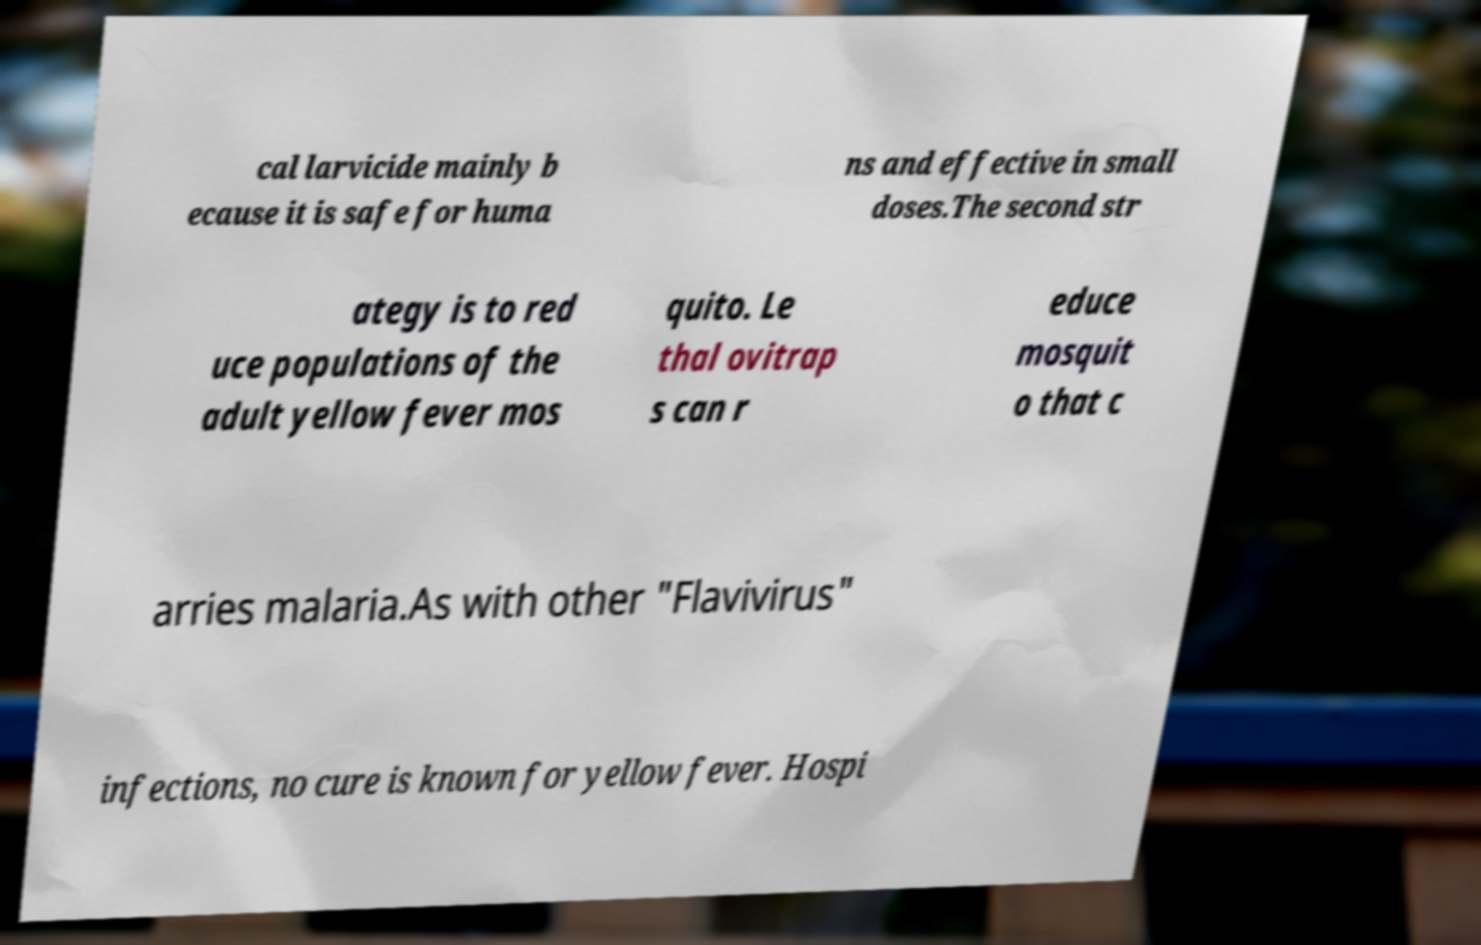Can you read and provide the text displayed in the image?This photo seems to have some interesting text. Can you extract and type it out for me? cal larvicide mainly b ecause it is safe for huma ns and effective in small doses.The second str ategy is to red uce populations of the adult yellow fever mos quito. Le thal ovitrap s can r educe mosquit o that c arries malaria.As with other "Flavivirus" infections, no cure is known for yellow fever. Hospi 